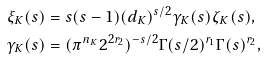<formula> <loc_0><loc_0><loc_500><loc_500>\xi _ { K } ( s ) & = s ( s - 1 ) ( d _ { K } ) ^ { s / 2 } \gamma _ { K } ( s ) \zeta _ { K } ( s ) , \\ \gamma _ { K } ( s ) & = ( \pi ^ { n _ { K } } 2 ^ { 2 r _ { 2 } } ) ^ { - s / 2 } \Gamma ( s / 2 ) ^ { r _ { 1 } } \Gamma ( s ) ^ { r _ { 2 } } ,</formula> 